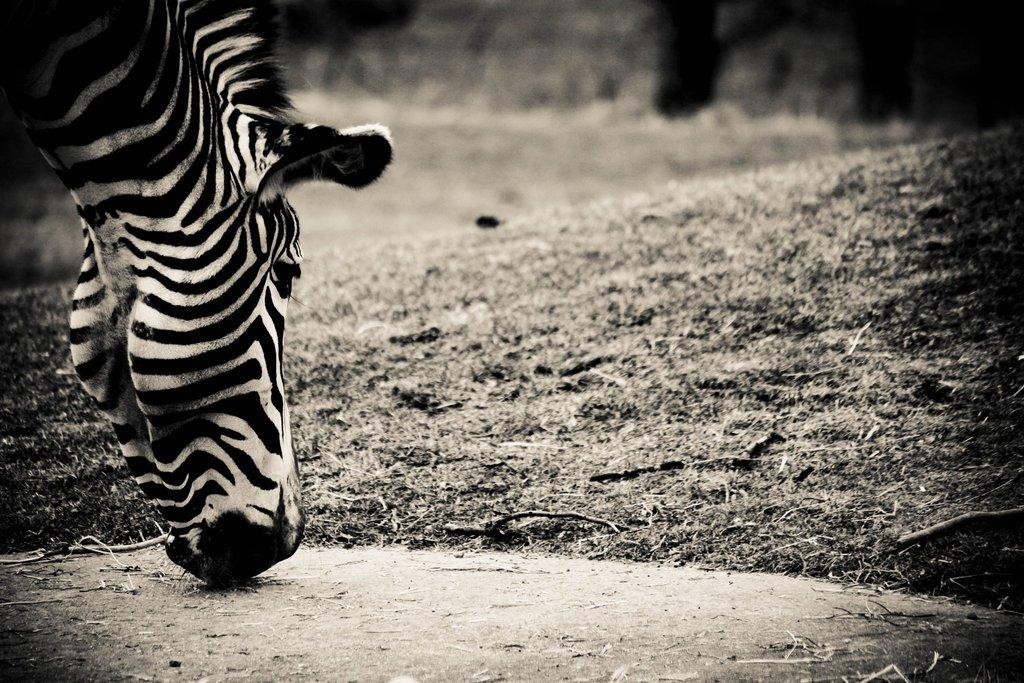What is the color scheme of the image? The image is black and white. What animal can be seen in the image? There is a giraffe in the image. Where is the giraffe located in the image? The giraffe is on the ground. What type of cabbage is being used to make a statement in the image? There is no cabbage or statement present in the image; it features a black and white image of a giraffe on the ground. 